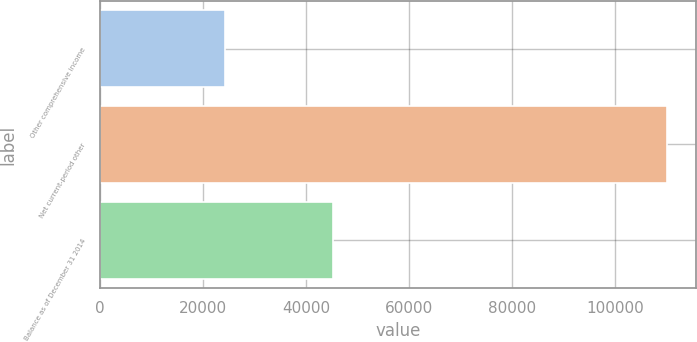<chart> <loc_0><loc_0><loc_500><loc_500><bar_chart><fcel>Other comprehensive income<fcel>Net current-period other<fcel>Balance as of December 31 2014<nl><fcel>24247<fcel>110104<fcel>45122<nl></chart> 